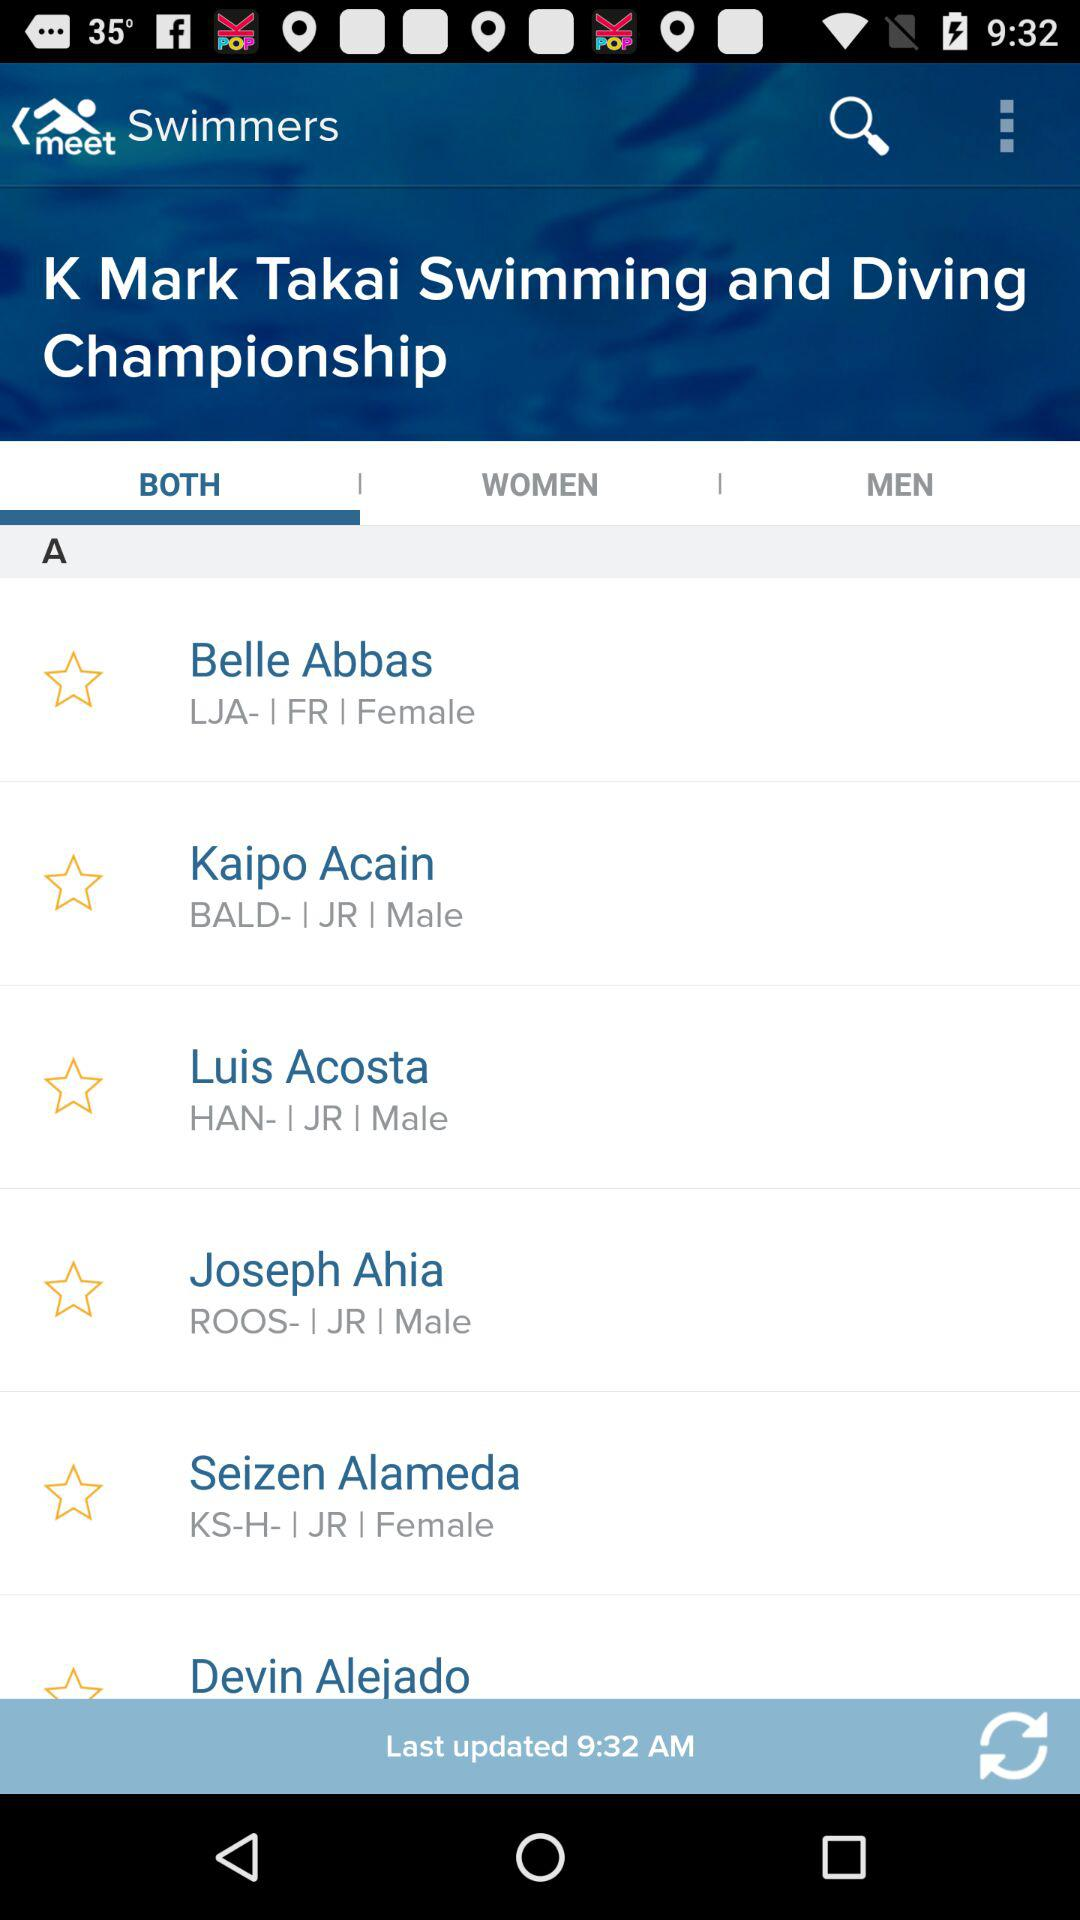What is the name of the application? The name of the application is "meet". 